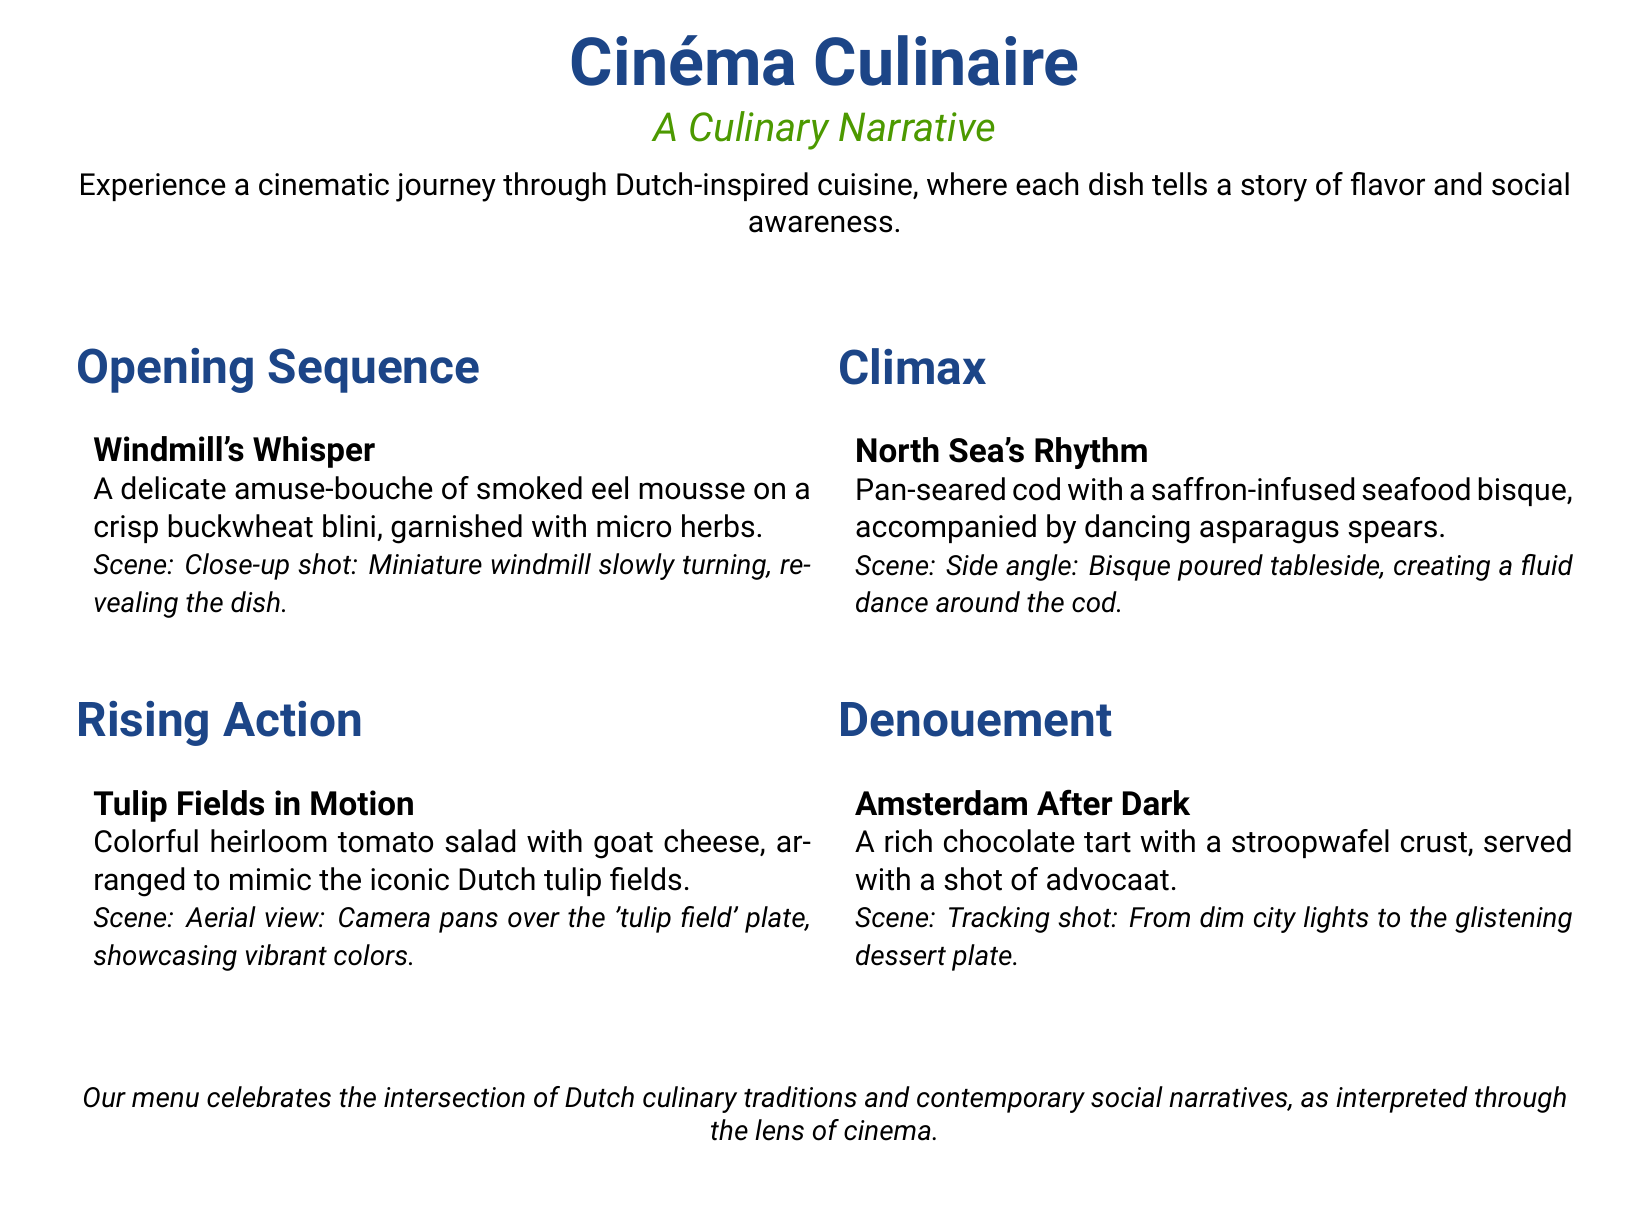What is the title of the menu? The title is prominently displayed at the top of the document, indicating the theme of the menu.
Answer: Cinéma Culinaire What is the first dish listed on the menu? The first dish represents the opening sequence of the culinary narrative.
Answer: Windmill's Whisper What type of cheese is used in the second dish? The second dish features goat cheese, which is part of the colorful salad intended to mimic tulip fields.
Answer: Goat cheese What is included with Amsterdam After Dark? The dessert is served with a specific Dutch liqueur that enhances the flavor experience.
Answer: A shot of advocaat What culinary concept does the menu celebrate? The overarching theme of the menu combines aspects of food, culture, and artistry.
Answer: The intersection of Dutch culinary traditions and contemporary social narratives What is the last dish served in the menu's story? The last dish concludes the culinary narrative, tying together the narrative journey.
Answer: Amsterdam After Dark What color is prominent in the menu's design? The design of the menu incorporates a specific shade that aligns with the cinematic theme.
Answer: Film blue How many sections are in the menu? The menu is organized into specific narrative sections that correspond to its cinematic theme.
Answer: Four 